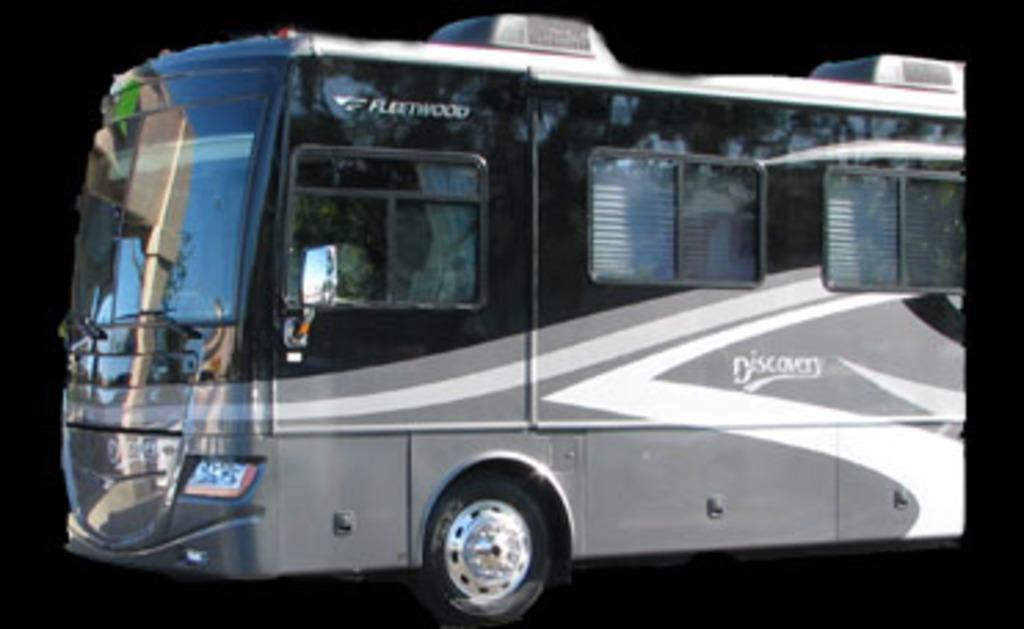Could you give a brief overview of what you see in this image? This is an edited image. Here I can see an image of a bus towards the left side. The background is in black color. 